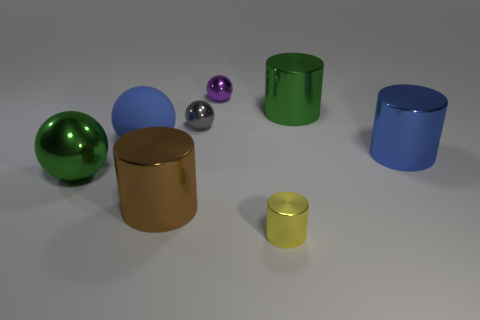Subtract all metal balls. How many balls are left? 1 Subtract 3 cylinders. How many cylinders are left? 1 Add 1 green balls. How many objects exist? 9 Subtract all blue spheres. How many spheres are left? 3 Subtract all green metallic cylinders. Subtract all small gray balls. How many objects are left? 6 Add 4 small gray objects. How many small gray objects are left? 5 Add 8 purple balls. How many purple balls exist? 9 Subtract 0 red cubes. How many objects are left? 8 Subtract all cyan balls. Subtract all blue cylinders. How many balls are left? 4 Subtract all blue cubes. How many purple cylinders are left? 0 